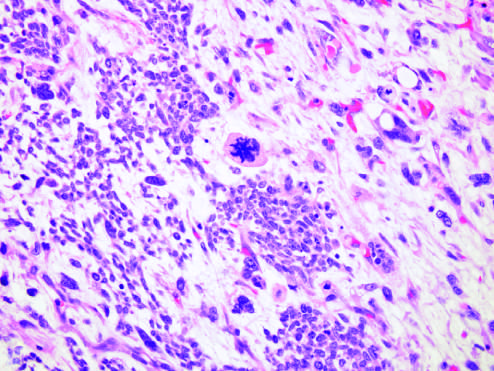what are predominance of blastemal morphology and diffuse anaplasia associated with?
Answer the question using a single word or phrase. Specific molecular lesions 